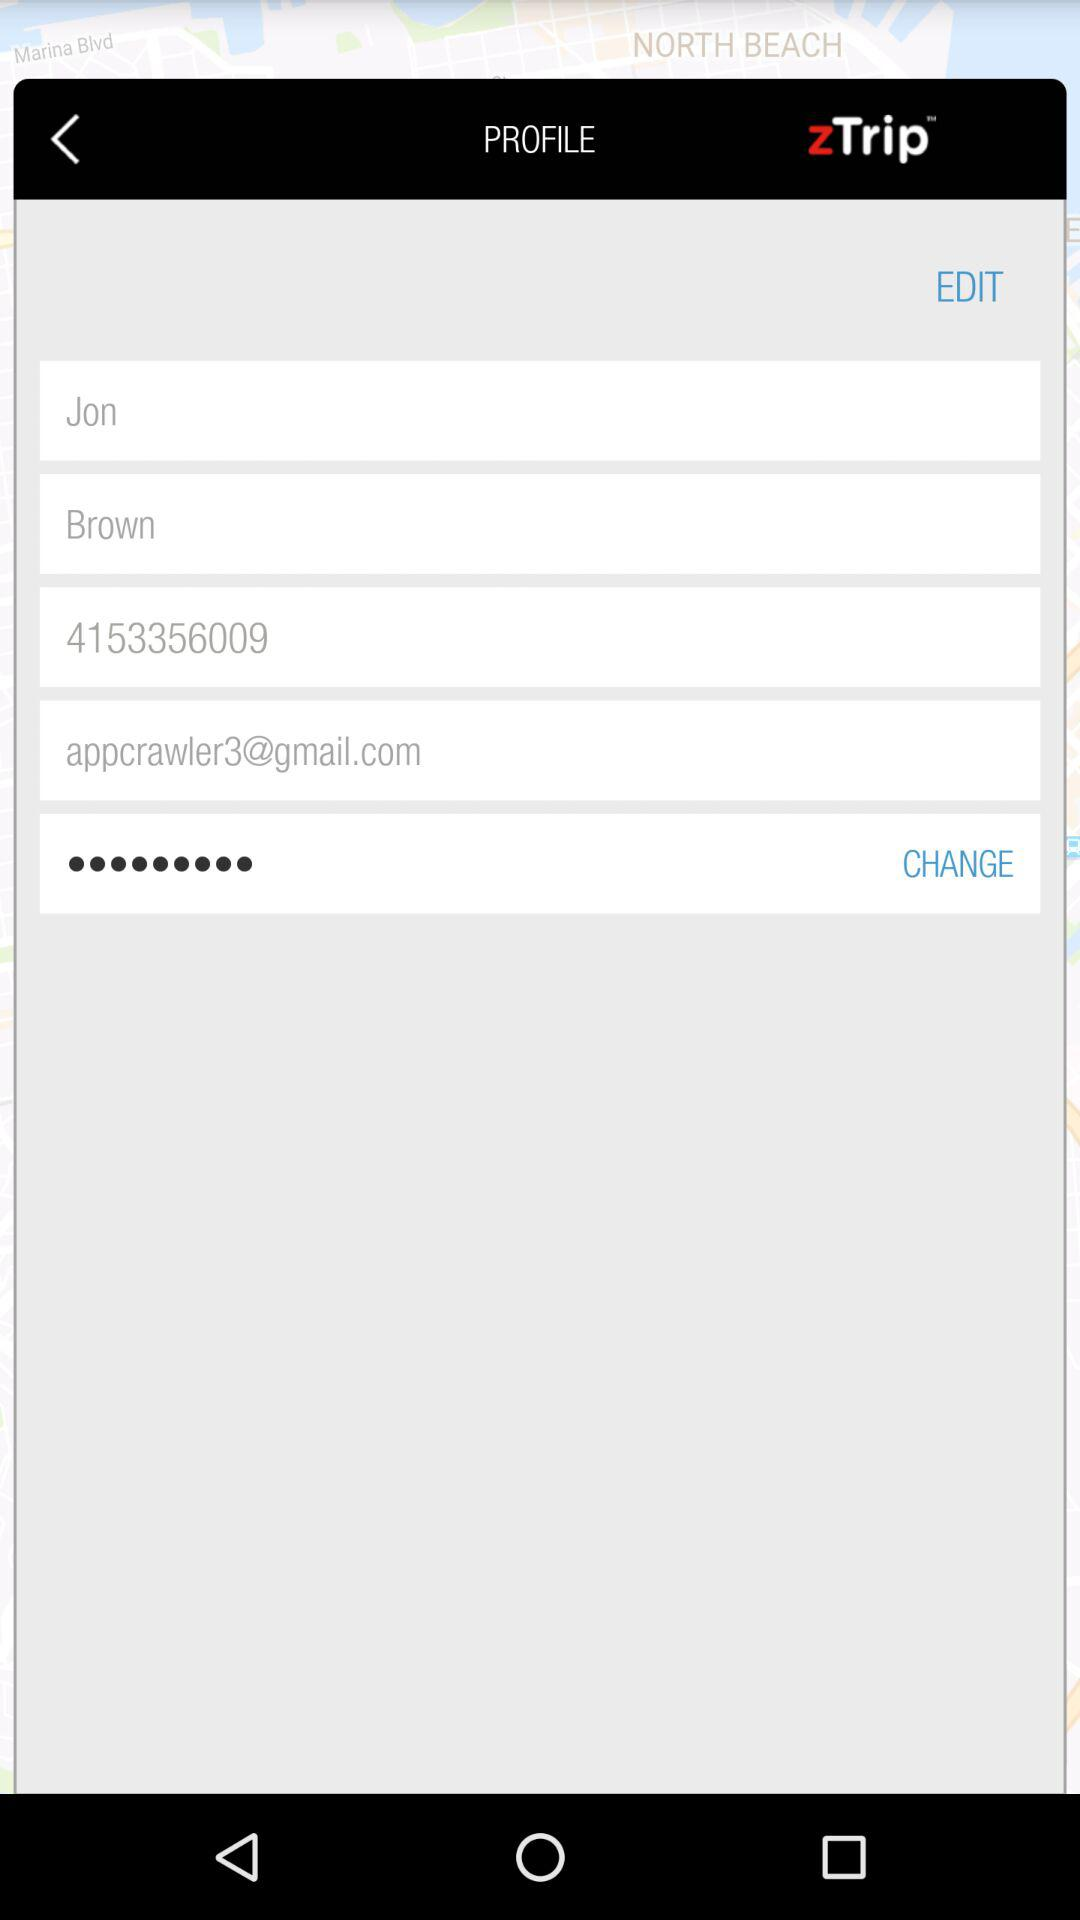What is the application name? The application name is "zTrip". 